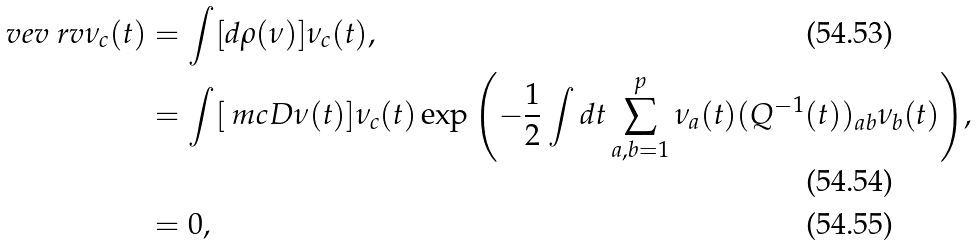Convert formula to latex. <formula><loc_0><loc_0><loc_500><loc_500>\ v e v { \ r v { \nu } _ { c } ( t ) } & = \int [ d \rho ( \nu ) ] \nu _ { c } ( t ) , \\ & = \int [ \ m c { D } \nu ( t ) ] \nu _ { c } ( t ) \exp { \left ( - \frac { 1 } { 2 } \int d t \sum _ { a , b = 1 } ^ { p } \nu _ { a } ( t ) ( Q ^ { - 1 } ( t ) ) _ { a b } \nu _ { b } ( t ) \right ) } , \\ & = 0 ,</formula> 